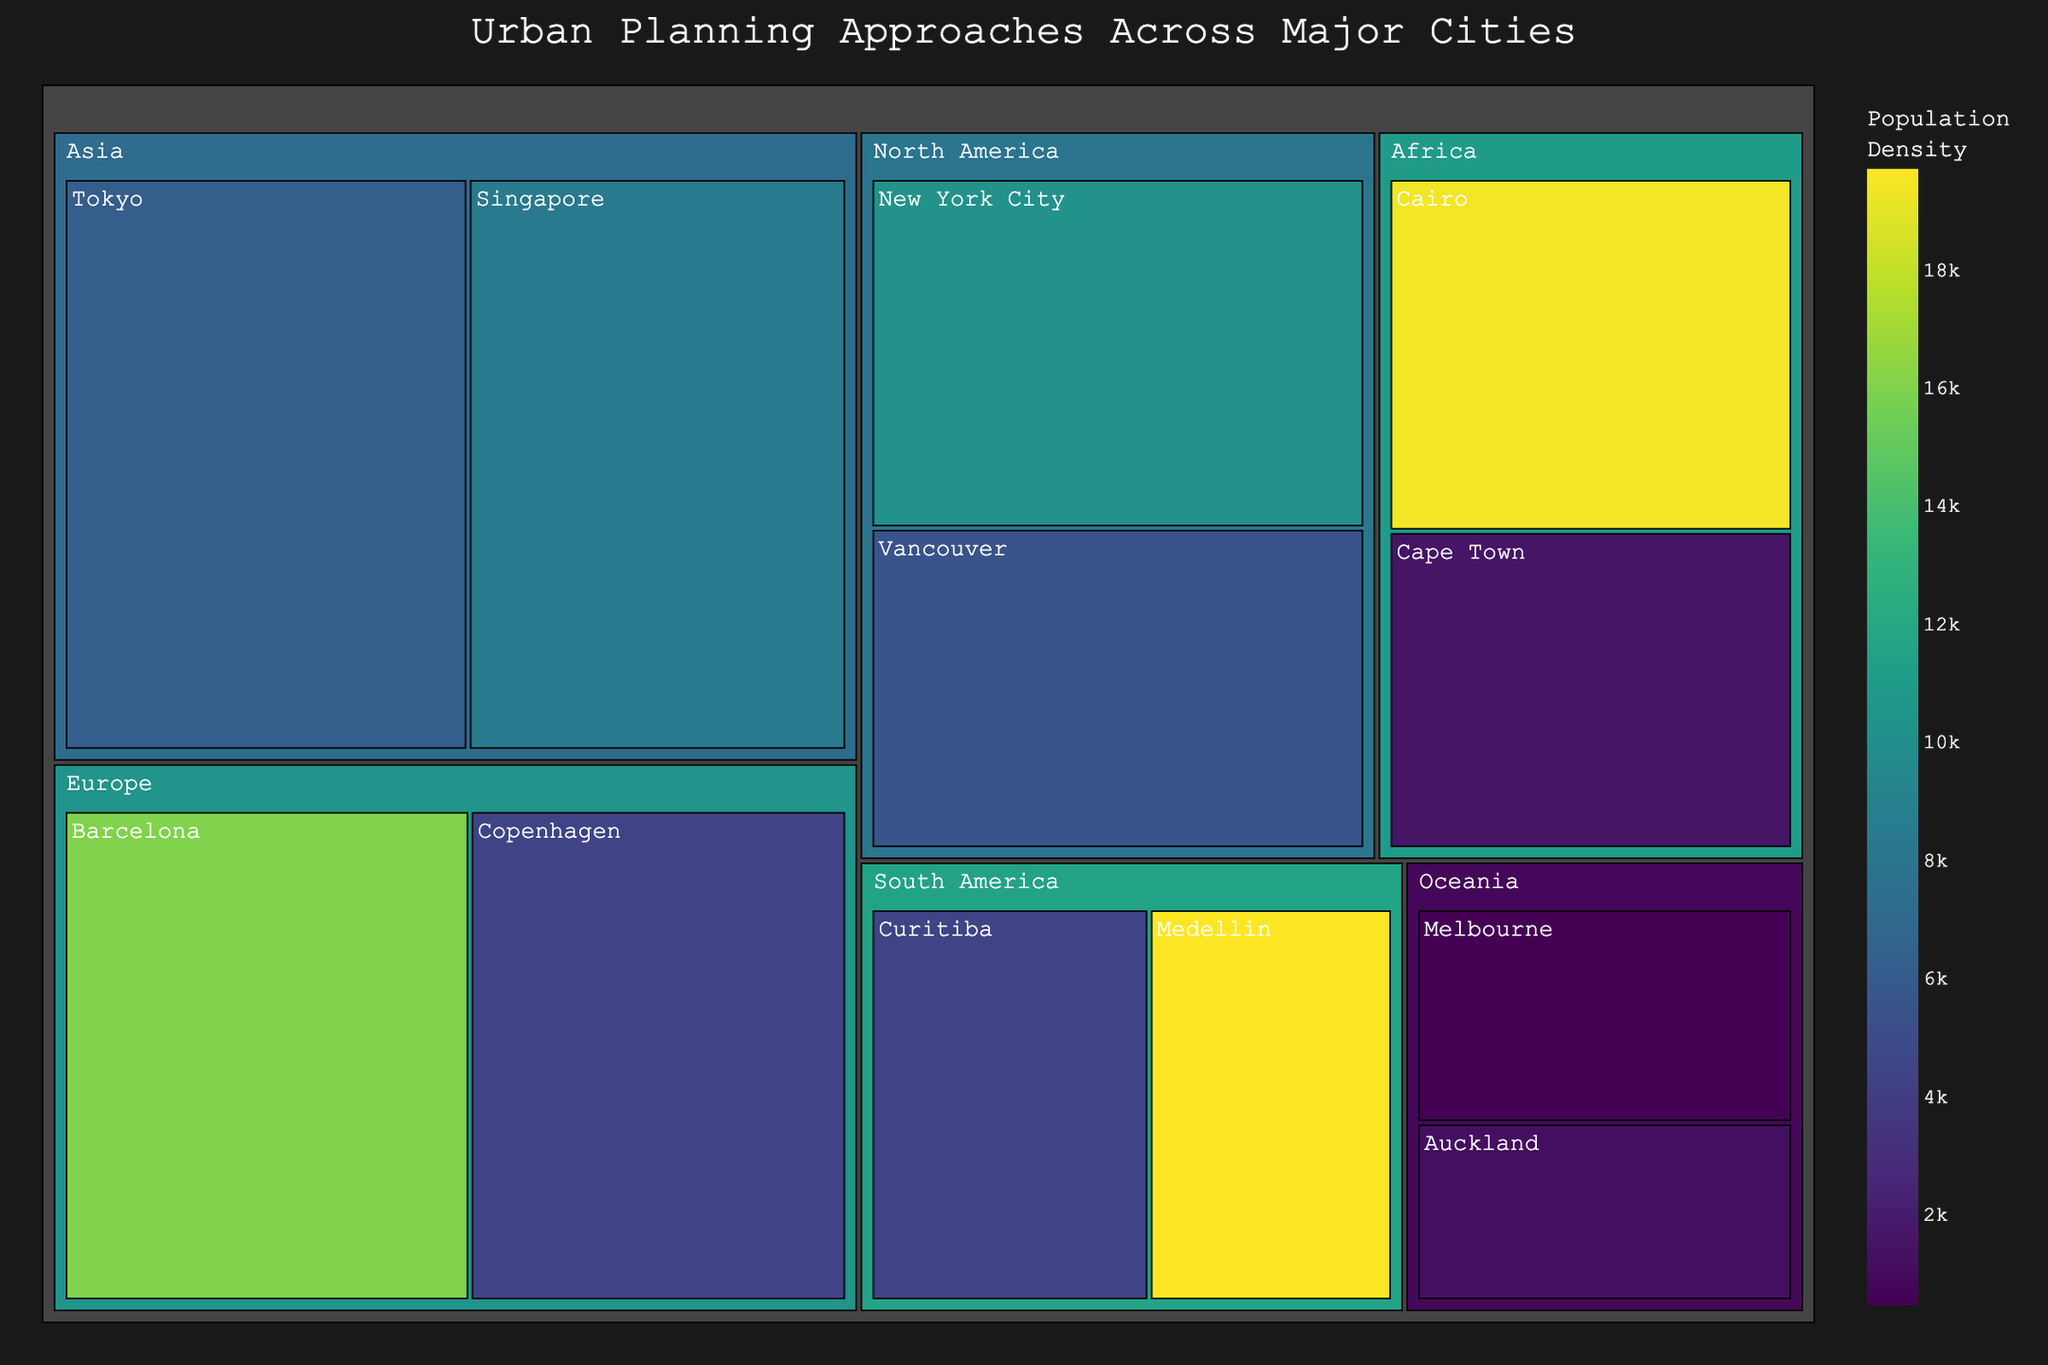What is the title of the treemap? The title is generally located at the top of the treemap and it provides a brief summary of what the treemap is about. In this case, it reads "Urban Planning Approaches Across Major Cities"
Answer: Urban Planning Approaches Across Major Cities Which continent has the city with the highest population density? To determine this, we look for the city with the highest population density mentioned in the hover data. Cairo in Africa has the highest population density of 19,376.
Answer: Africa What urban planning approach is used in Tokyo? Hovering over the Tokyo section on the treemap reveals its urban planning approach. The hover data indicates that Tokyo uses "Transit-Oriented Development".
Answer: Transit-Oriented Development Which city in Europe has the highest population density? By comparing the population densities of European cities in the treemap, we find that Barcelona, with a density of 16,000, has the highest population density in Europe.
Answer: Barcelona What is the sum of the values for all cities in North America? North America includes New York City (60) and Vancouver (55). Summing these values gives 60 + 55 = 115.
Answer: 115 Which city in Oceania has a larger value, Melbourne or Auckland? We compare the values for Melbourne and Auckland shown in the treemap. Melbourne has a value of 30, whereas Auckland has a value of 25. Therefore, Melbourne has the larger value.
Answer: Melbourne What is the average population density of the cities in South America? South America includes Curitiba (4405) and Medellin (19700). The average population density is calculated by (4405 + 19700) / 2 = 12,052.5.
Answer: 12,052.5 Which continent has more cities represented in the treemap, Asia or Oceania? By counting the cities represented in the treemap, we find that Asia has two cities (Tokyo and Singapore) and Oceania has two cities (Melbourne and Auckland). Therefore, both continents have an equal number of cities represented.
Answer: Equal What urban planning approach is used in Cairo? Hovering over the Cairo section on the treemap reveals its urban planning approach. The hover data indicates that Cairo uses "Informal Settlement Upgrading".
Answer: Informal Settlement Upgrading 